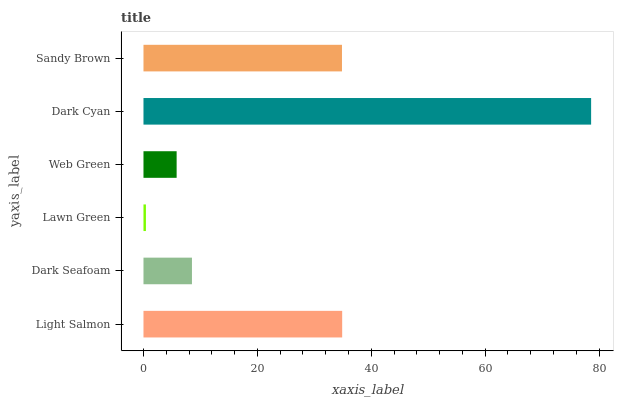Is Lawn Green the minimum?
Answer yes or no. Yes. Is Dark Cyan the maximum?
Answer yes or no. Yes. Is Dark Seafoam the minimum?
Answer yes or no. No. Is Dark Seafoam the maximum?
Answer yes or no. No. Is Light Salmon greater than Dark Seafoam?
Answer yes or no. Yes. Is Dark Seafoam less than Light Salmon?
Answer yes or no. Yes. Is Dark Seafoam greater than Light Salmon?
Answer yes or no. No. Is Light Salmon less than Dark Seafoam?
Answer yes or no. No. Is Sandy Brown the high median?
Answer yes or no. Yes. Is Dark Seafoam the low median?
Answer yes or no. Yes. Is Dark Cyan the high median?
Answer yes or no. No. Is Sandy Brown the low median?
Answer yes or no. No. 